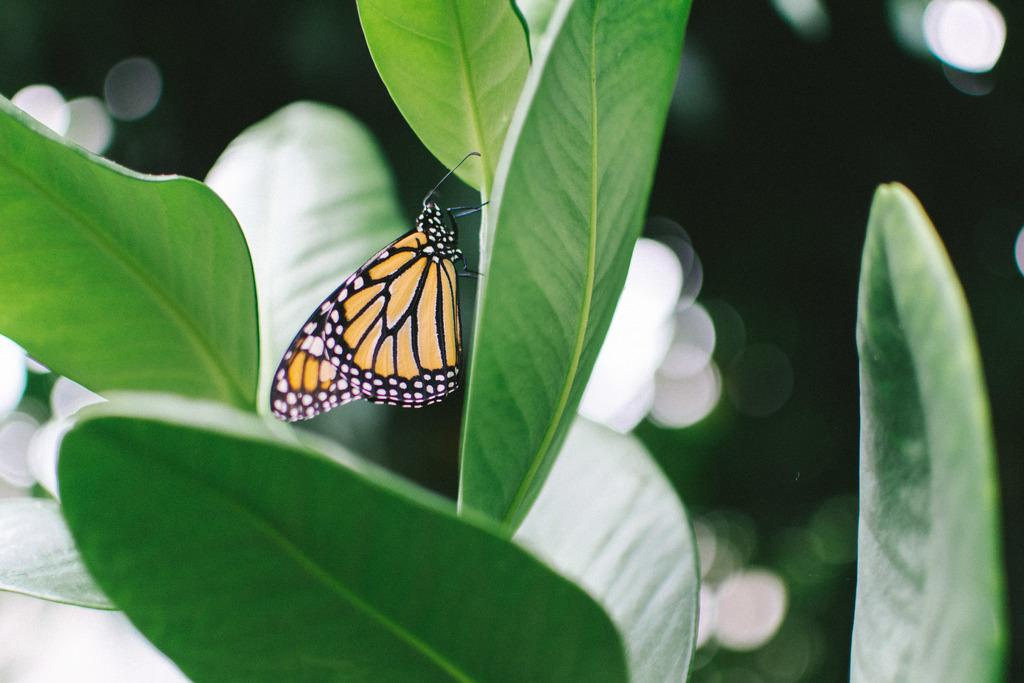What is the main subject of the image? There is a butterfly in the image. Where is the butterfly located? The butterfly is on a leaf. Can you describe the background of the image? The background of the image is blurry. How many men are present in the image? There are no men present in the image; it features a butterfly on a leaf. What day of the week is depicted in the image? The image does not depict a specific day of the week; it only shows a butterfly on a leaf. 